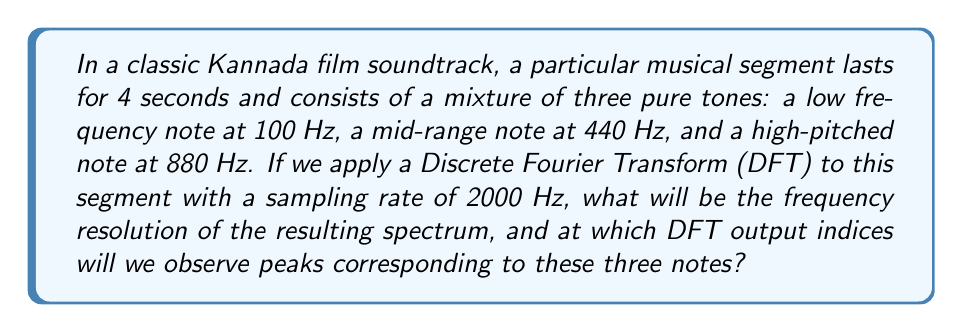What is the answer to this math problem? To solve this problem, we need to follow these steps:

1. Calculate the frequency resolution:
   The frequency resolution (Δf) is given by:
   $$\Delta f = \frac{f_s}{N}$$
   where $f_s$ is the sampling rate and $N$ is the number of samples.

   We know $f_s = 2000$ Hz and the duration is 4 seconds, so:
   $N = 2000 \text{ Hz} \times 4 \text{ s} = 8000 \text{ samples}$

   Therefore:
   $$\Delta f = \frac{2000 \text{ Hz}}{8000} = 0.25 \text{ Hz}$$

2. Find the DFT output indices:
   The index $k$ for a given frequency $f$ in the DFT output is:
   $$k = \frac{f}{\Delta f} = \frac{f}{0.25 \text{ Hz}} = 4f$$

   For 100 Hz: $k_{100} = 4 \times 100 = 400$
   For 440 Hz: $k_{440} = 4 \times 440 = 1760$
   For 880 Hz: $k_{880} = 4 \times 880 = 3520$

These indices represent the locations in the DFT output array where we would observe peaks corresponding to the three notes in the soundtrack.
Answer: The frequency resolution is 0.25 Hz. The peaks will be observed at DFT output indices 400, 1760, and 3520. 